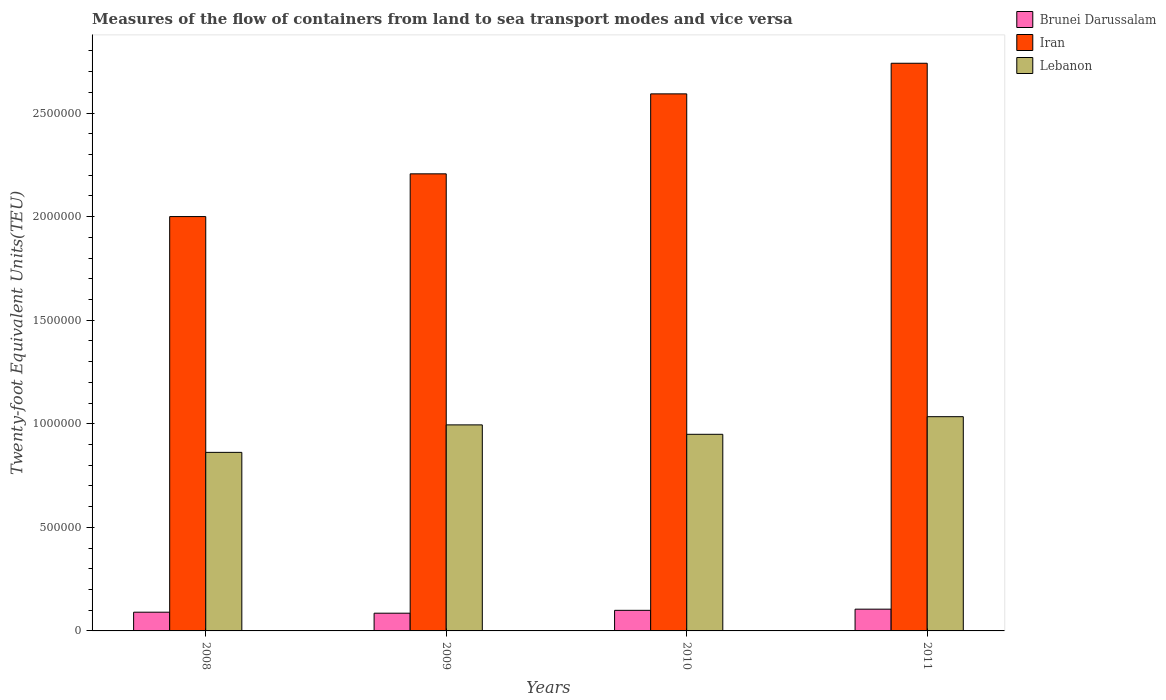How many groups of bars are there?
Make the answer very short. 4. Are the number of bars per tick equal to the number of legend labels?
Make the answer very short. Yes. How many bars are there on the 1st tick from the left?
Offer a terse response. 3. How many bars are there on the 2nd tick from the right?
Your answer should be compact. 3. What is the label of the 2nd group of bars from the left?
Your answer should be very brief. 2009. In how many cases, is the number of bars for a given year not equal to the number of legend labels?
Keep it short and to the point. 0. What is the container port traffic in Brunei Darussalam in 2010?
Ensure brevity in your answer.  9.94e+04. Across all years, what is the maximum container port traffic in Iran?
Your response must be concise. 2.74e+06. Across all years, what is the minimum container port traffic in Iran?
Your response must be concise. 2.00e+06. In which year was the container port traffic in Lebanon maximum?
Provide a short and direct response. 2011. What is the total container port traffic in Lebanon in the graph?
Ensure brevity in your answer.  3.84e+06. What is the difference between the container port traffic in Lebanon in 2008 and that in 2010?
Give a very brief answer. -8.72e+04. What is the difference between the container port traffic in Iran in 2011 and the container port traffic in Lebanon in 2008?
Offer a very short reply. 1.88e+06. What is the average container port traffic in Brunei Darussalam per year?
Your answer should be very brief. 9.51e+04. In the year 2009, what is the difference between the container port traffic in Iran and container port traffic in Lebanon?
Make the answer very short. 1.21e+06. What is the ratio of the container port traffic in Iran in 2009 to that in 2011?
Your response must be concise. 0.81. Is the container port traffic in Iran in 2008 less than that in 2009?
Offer a terse response. Yes. What is the difference between the highest and the second highest container port traffic in Iran?
Offer a very short reply. 1.48e+05. What is the difference between the highest and the lowest container port traffic in Lebanon?
Your answer should be very brief. 1.72e+05. Is the sum of the container port traffic in Brunei Darussalam in 2008 and 2011 greater than the maximum container port traffic in Lebanon across all years?
Make the answer very short. No. What does the 2nd bar from the left in 2008 represents?
Give a very brief answer. Iran. What does the 1st bar from the right in 2008 represents?
Provide a succinct answer. Lebanon. Is it the case that in every year, the sum of the container port traffic in Iran and container port traffic in Brunei Darussalam is greater than the container port traffic in Lebanon?
Offer a very short reply. Yes. How many bars are there?
Keep it short and to the point. 12. How many years are there in the graph?
Your answer should be compact. 4. What is the difference between two consecutive major ticks on the Y-axis?
Keep it short and to the point. 5.00e+05. Are the values on the major ticks of Y-axis written in scientific E-notation?
Give a very brief answer. No. Does the graph contain any zero values?
Provide a short and direct response. No. Where does the legend appear in the graph?
Your response must be concise. Top right. How many legend labels are there?
Your answer should be very brief. 3. What is the title of the graph?
Your response must be concise. Measures of the flow of containers from land to sea transport modes and vice versa. What is the label or title of the Y-axis?
Give a very brief answer. Twenty-foot Equivalent Units(TEU). What is the Twenty-foot Equivalent Units(TEU) of Brunei Darussalam in 2008?
Make the answer very short. 9.04e+04. What is the Twenty-foot Equivalent Units(TEU) of Iran in 2008?
Your answer should be compact. 2.00e+06. What is the Twenty-foot Equivalent Units(TEU) in Lebanon in 2008?
Your response must be concise. 8.62e+05. What is the Twenty-foot Equivalent Units(TEU) in Brunei Darussalam in 2009?
Provide a succinct answer. 8.56e+04. What is the Twenty-foot Equivalent Units(TEU) in Iran in 2009?
Make the answer very short. 2.21e+06. What is the Twenty-foot Equivalent Units(TEU) in Lebanon in 2009?
Offer a terse response. 9.95e+05. What is the Twenty-foot Equivalent Units(TEU) in Brunei Darussalam in 2010?
Ensure brevity in your answer.  9.94e+04. What is the Twenty-foot Equivalent Units(TEU) of Iran in 2010?
Your answer should be very brief. 2.59e+06. What is the Twenty-foot Equivalent Units(TEU) of Lebanon in 2010?
Offer a terse response. 9.49e+05. What is the Twenty-foot Equivalent Units(TEU) of Brunei Darussalam in 2011?
Give a very brief answer. 1.05e+05. What is the Twenty-foot Equivalent Units(TEU) of Iran in 2011?
Your answer should be compact. 2.74e+06. What is the Twenty-foot Equivalent Units(TEU) of Lebanon in 2011?
Offer a terse response. 1.03e+06. Across all years, what is the maximum Twenty-foot Equivalent Units(TEU) in Brunei Darussalam?
Provide a short and direct response. 1.05e+05. Across all years, what is the maximum Twenty-foot Equivalent Units(TEU) of Iran?
Your answer should be compact. 2.74e+06. Across all years, what is the maximum Twenty-foot Equivalent Units(TEU) in Lebanon?
Your response must be concise. 1.03e+06. Across all years, what is the minimum Twenty-foot Equivalent Units(TEU) in Brunei Darussalam?
Ensure brevity in your answer.  8.56e+04. Across all years, what is the minimum Twenty-foot Equivalent Units(TEU) of Iran?
Your answer should be very brief. 2.00e+06. Across all years, what is the minimum Twenty-foot Equivalent Units(TEU) of Lebanon?
Keep it short and to the point. 8.62e+05. What is the total Twenty-foot Equivalent Units(TEU) of Brunei Darussalam in the graph?
Provide a short and direct response. 3.80e+05. What is the total Twenty-foot Equivalent Units(TEU) in Iran in the graph?
Provide a short and direct response. 9.54e+06. What is the total Twenty-foot Equivalent Units(TEU) in Lebanon in the graph?
Provide a short and direct response. 3.84e+06. What is the difference between the Twenty-foot Equivalent Units(TEU) in Brunei Darussalam in 2008 and that in 2009?
Offer a very short reply. 4789. What is the difference between the Twenty-foot Equivalent Units(TEU) in Iran in 2008 and that in 2009?
Provide a succinct answer. -2.06e+05. What is the difference between the Twenty-foot Equivalent Units(TEU) in Lebanon in 2008 and that in 2009?
Make the answer very short. -1.33e+05. What is the difference between the Twenty-foot Equivalent Units(TEU) in Brunei Darussalam in 2008 and that in 2010?
Offer a very short reply. -8988.9. What is the difference between the Twenty-foot Equivalent Units(TEU) in Iran in 2008 and that in 2010?
Give a very brief answer. -5.92e+05. What is the difference between the Twenty-foot Equivalent Units(TEU) of Lebanon in 2008 and that in 2010?
Give a very brief answer. -8.72e+04. What is the difference between the Twenty-foot Equivalent Units(TEU) in Brunei Darussalam in 2008 and that in 2011?
Offer a terse response. -1.47e+04. What is the difference between the Twenty-foot Equivalent Units(TEU) in Iran in 2008 and that in 2011?
Offer a very short reply. -7.40e+05. What is the difference between the Twenty-foot Equivalent Units(TEU) in Lebanon in 2008 and that in 2011?
Your answer should be very brief. -1.72e+05. What is the difference between the Twenty-foot Equivalent Units(TEU) of Brunei Darussalam in 2009 and that in 2010?
Give a very brief answer. -1.38e+04. What is the difference between the Twenty-foot Equivalent Units(TEU) in Iran in 2009 and that in 2010?
Your response must be concise. -3.86e+05. What is the difference between the Twenty-foot Equivalent Units(TEU) of Lebanon in 2009 and that in 2010?
Provide a short and direct response. 4.54e+04. What is the difference between the Twenty-foot Equivalent Units(TEU) of Brunei Darussalam in 2009 and that in 2011?
Provide a succinct answer. -1.94e+04. What is the difference between the Twenty-foot Equivalent Units(TEU) in Iran in 2009 and that in 2011?
Your answer should be compact. -5.34e+05. What is the difference between the Twenty-foot Equivalent Units(TEU) in Lebanon in 2009 and that in 2011?
Your answer should be compact. -3.96e+04. What is the difference between the Twenty-foot Equivalent Units(TEU) of Brunei Darussalam in 2010 and that in 2011?
Offer a very short reply. -5663.23. What is the difference between the Twenty-foot Equivalent Units(TEU) in Iran in 2010 and that in 2011?
Make the answer very short. -1.48e+05. What is the difference between the Twenty-foot Equivalent Units(TEU) in Lebanon in 2010 and that in 2011?
Provide a short and direct response. -8.51e+04. What is the difference between the Twenty-foot Equivalent Units(TEU) of Brunei Darussalam in 2008 and the Twenty-foot Equivalent Units(TEU) of Iran in 2009?
Your answer should be very brief. -2.12e+06. What is the difference between the Twenty-foot Equivalent Units(TEU) in Brunei Darussalam in 2008 and the Twenty-foot Equivalent Units(TEU) in Lebanon in 2009?
Provide a short and direct response. -9.04e+05. What is the difference between the Twenty-foot Equivalent Units(TEU) of Iran in 2008 and the Twenty-foot Equivalent Units(TEU) of Lebanon in 2009?
Make the answer very short. 1.01e+06. What is the difference between the Twenty-foot Equivalent Units(TEU) in Brunei Darussalam in 2008 and the Twenty-foot Equivalent Units(TEU) in Iran in 2010?
Provide a short and direct response. -2.50e+06. What is the difference between the Twenty-foot Equivalent Units(TEU) of Brunei Darussalam in 2008 and the Twenty-foot Equivalent Units(TEU) of Lebanon in 2010?
Give a very brief answer. -8.59e+05. What is the difference between the Twenty-foot Equivalent Units(TEU) of Iran in 2008 and the Twenty-foot Equivalent Units(TEU) of Lebanon in 2010?
Ensure brevity in your answer.  1.05e+06. What is the difference between the Twenty-foot Equivalent Units(TEU) in Brunei Darussalam in 2008 and the Twenty-foot Equivalent Units(TEU) in Iran in 2011?
Provide a short and direct response. -2.65e+06. What is the difference between the Twenty-foot Equivalent Units(TEU) of Brunei Darussalam in 2008 and the Twenty-foot Equivalent Units(TEU) of Lebanon in 2011?
Offer a very short reply. -9.44e+05. What is the difference between the Twenty-foot Equivalent Units(TEU) in Iran in 2008 and the Twenty-foot Equivalent Units(TEU) in Lebanon in 2011?
Keep it short and to the point. 9.66e+05. What is the difference between the Twenty-foot Equivalent Units(TEU) in Brunei Darussalam in 2009 and the Twenty-foot Equivalent Units(TEU) in Iran in 2010?
Offer a terse response. -2.51e+06. What is the difference between the Twenty-foot Equivalent Units(TEU) of Brunei Darussalam in 2009 and the Twenty-foot Equivalent Units(TEU) of Lebanon in 2010?
Keep it short and to the point. -8.64e+05. What is the difference between the Twenty-foot Equivalent Units(TEU) in Iran in 2009 and the Twenty-foot Equivalent Units(TEU) in Lebanon in 2010?
Your response must be concise. 1.26e+06. What is the difference between the Twenty-foot Equivalent Units(TEU) of Brunei Darussalam in 2009 and the Twenty-foot Equivalent Units(TEU) of Iran in 2011?
Make the answer very short. -2.65e+06. What is the difference between the Twenty-foot Equivalent Units(TEU) of Brunei Darussalam in 2009 and the Twenty-foot Equivalent Units(TEU) of Lebanon in 2011?
Your response must be concise. -9.49e+05. What is the difference between the Twenty-foot Equivalent Units(TEU) of Iran in 2009 and the Twenty-foot Equivalent Units(TEU) of Lebanon in 2011?
Your answer should be compact. 1.17e+06. What is the difference between the Twenty-foot Equivalent Units(TEU) of Brunei Darussalam in 2010 and the Twenty-foot Equivalent Units(TEU) of Iran in 2011?
Give a very brief answer. -2.64e+06. What is the difference between the Twenty-foot Equivalent Units(TEU) of Brunei Darussalam in 2010 and the Twenty-foot Equivalent Units(TEU) of Lebanon in 2011?
Your answer should be compact. -9.35e+05. What is the difference between the Twenty-foot Equivalent Units(TEU) of Iran in 2010 and the Twenty-foot Equivalent Units(TEU) of Lebanon in 2011?
Provide a succinct answer. 1.56e+06. What is the average Twenty-foot Equivalent Units(TEU) of Brunei Darussalam per year?
Your answer should be very brief. 9.51e+04. What is the average Twenty-foot Equivalent Units(TEU) of Iran per year?
Your answer should be very brief. 2.38e+06. What is the average Twenty-foot Equivalent Units(TEU) in Lebanon per year?
Your answer should be very brief. 9.60e+05. In the year 2008, what is the difference between the Twenty-foot Equivalent Units(TEU) in Brunei Darussalam and Twenty-foot Equivalent Units(TEU) in Iran?
Offer a very short reply. -1.91e+06. In the year 2008, what is the difference between the Twenty-foot Equivalent Units(TEU) of Brunei Darussalam and Twenty-foot Equivalent Units(TEU) of Lebanon?
Offer a very short reply. -7.72e+05. In the year 2008, what is the difference between the Twenty-foot Equivalent Units(TEU) of Iran and Twenty-foot Equivalent Units(TEU) of Lebanon?
Make the answer very short. 1.14e+06. In the year 2009, what is the difference between the Twenty-foot Equivalent Units(TEU) in Brunei Darussalam and Twenty-foot Equivalent Units(TEU) in Iran?
Keep it short and to the point. -2.12e+06. In the year 2009, what is the difference between the Twenty-foot Equivalent Units(TEU) in Brunei Darussalam and Twenty-foot Equivalent Units(TEU) in Lebanon?
Your response must be concise. -9.09e+05. In the year 2009, what is the difference between the Twenty-foot Equivalent Units(TEU) in Iran and Twenty-foot Equivalent Units(TEU) in Lebanon?
Make the answer very short. 1.21e+06. In the year 2010, what is the difference between the Twenty-foot Equivalent Units(TEU) of Brunei Darussalam and Twenty-foot Equivalent Units(TEU) of Iran?
Provide a short and direct response. -2.49e+06. In the year 2010, what is the difference between the Twenty-foot Equivalent Units(TEU) in Brunei Darussalam and Twenty-foot Equivalent Units(TEU) in Lebanon?
Ensure brevity in your answer.  -8.50e+05. In the year 2010, what is the difference between the Twenty-foot Equivalent Units(TEU) of Iran and Twenty-foot Equivalent Units(TEU) of Lebanon?
Your answer should be compact. 1.64e+06. In the year 2011, what is the difference between the Twenty-foot Equivalent Units(TEU) of Brunei Darussalam and Twenty-foot Equivalent Units(TEU) of Iran?
Your response must be concise. -2.64e+06. In the year 2011, what is the difference between the Twenty-foot Equivalent Units(TEU) in Brunei Darussalam and Twenty-foot Equivalent Units(TEU) in Lebanon?
Offer a very short reply. -9.29e+05. In the year 2011, what is the difference between the Twenty-foot Equivalent Units(TEU) in Iran and Twenty-foot Equivalent Units(TEU) in Lebanon?
Provide a short and direct response. 1.71e+06. What is the ratio of the Twenty-foot Equivalent Units(TEU) in Brunei Darussalam in 2008 to that in 2009?
Give a very brief answer. 1.06. What is the ratio of the Twenty-foot Equivalent Units(TEU) in Iran in 2008 to that in 2009?
Offer a terse response. 0.91. What is the ratio of the Twenty-foot Equivalent Units(TEU) in Lebanon in 2008 to that in 2009?
Keep it short and to the point. 0.87. What is the ratio of the Twenty-foot Equivalent Units(TEU) in Brunei Darussalam in 2008 to that in 2010?
Your answer should be very brief. 0.91. What is the ratio of the Twenty-foot Equivalent Units(TEU) of Iran in 2008 to that in 2010?
Make the answer very short. 0.77. What is the ratio of the Twenty-foot Equivalent Units(TEU) of Lebanon in 2008 to that in 2010?
Ensure brevity in your answer.  0.91. What is the ratio of the Twenty-foot Equivalent Units(TEU) of Brunei Darussalam in 2008 to that in 2011?
Your response must be concise. 0.86. What is the ratio of the Twenty-foot Equivalent Units(TEU) in Iran in 2008 to that in 2011?
Give a very brief answer. 0.73. What is the ratio of the Twenty-foot Equivalent Units(TEU) of Lebanon in 2008 to that in 2011?
Offer a very short reply. 0.83. What is the ratio of the Twenty-foot Equivalent Units(TEU) of Brunei Darussalam in 2009 to that in 2010?
Your answer should be very brief. 0.86. What is the ratio of the Twenty-foot Equivalent Units(TEU) in Iran in 2009 to that in 2010?
Make the answer very short. 0.85. What is the ratio of the Twenty-foot Equivalent Units(TEU) of Lebanon in 2009 to that in 2010?
Give a very brief answer. 1.05. What is the ratio of the Twenty-foot Equivalent Units(TEU) of Brunei Darussalam in 2009 to that in 2011?
Provide a short and direct response. 0.81. What is the ratio of the Twenty-foot Equivalent Units(TEU) of Iran in 2009 to that in 2011?
Ensure brevity in your answer.  0.81. What is the ratio of the Twenty-foot Equivalent Units(TEU) in Lebanon in 2009 to that in 2011?
Make the answer very short. 0.96. What is the ratio of the Twenty-foot Equivalent Units(TEU) in Brunei Darussalam in 2010 to that in 2011?
Make the answer very short. 0.95. What is the ratio of the Twenty-foot Equivalent Units(TEU) of Iran in 2010 to that in 2011?
Your answer should be compact. 0.95. What is the ratio of the Twenty-foot Equivalent Units(TEU) of Lebanon in 2010 to that in 2011?
Offer a very short reply. 0.92. What is the difference between the highest and the second highest Twenty-foot Equivalent Units(TEU) in Brunei Darussalam?
Your answer should be very brief. 5663.23. What is the difference between the highest and the second highest Twenty-foot Equivalent Units(TEU) of Iran?
Make the answer very short. 1.48e+05. What is the difference between the highest and the second highest Twenty-foot Equivalent Units(TEU) of Lebanon?
Provide a succinct answer. 3.96e+04. What is the difference between the highest and the lowest Twenty-foot Equivalent Units(TEU) of Brunei Darussalam?
Your answer should be very brief. 1.94e+04. What is the difference between the highest and the lowest Twenty-foot Equivalent Units(TEU) of Iran?
Make the answer very short. 7.40e+05. What is the difference between the highest and the lowest Twenty-foot Equivalent Units(TEU) in Lebanon?
Provide a short and direct response. 1.72e+05. 